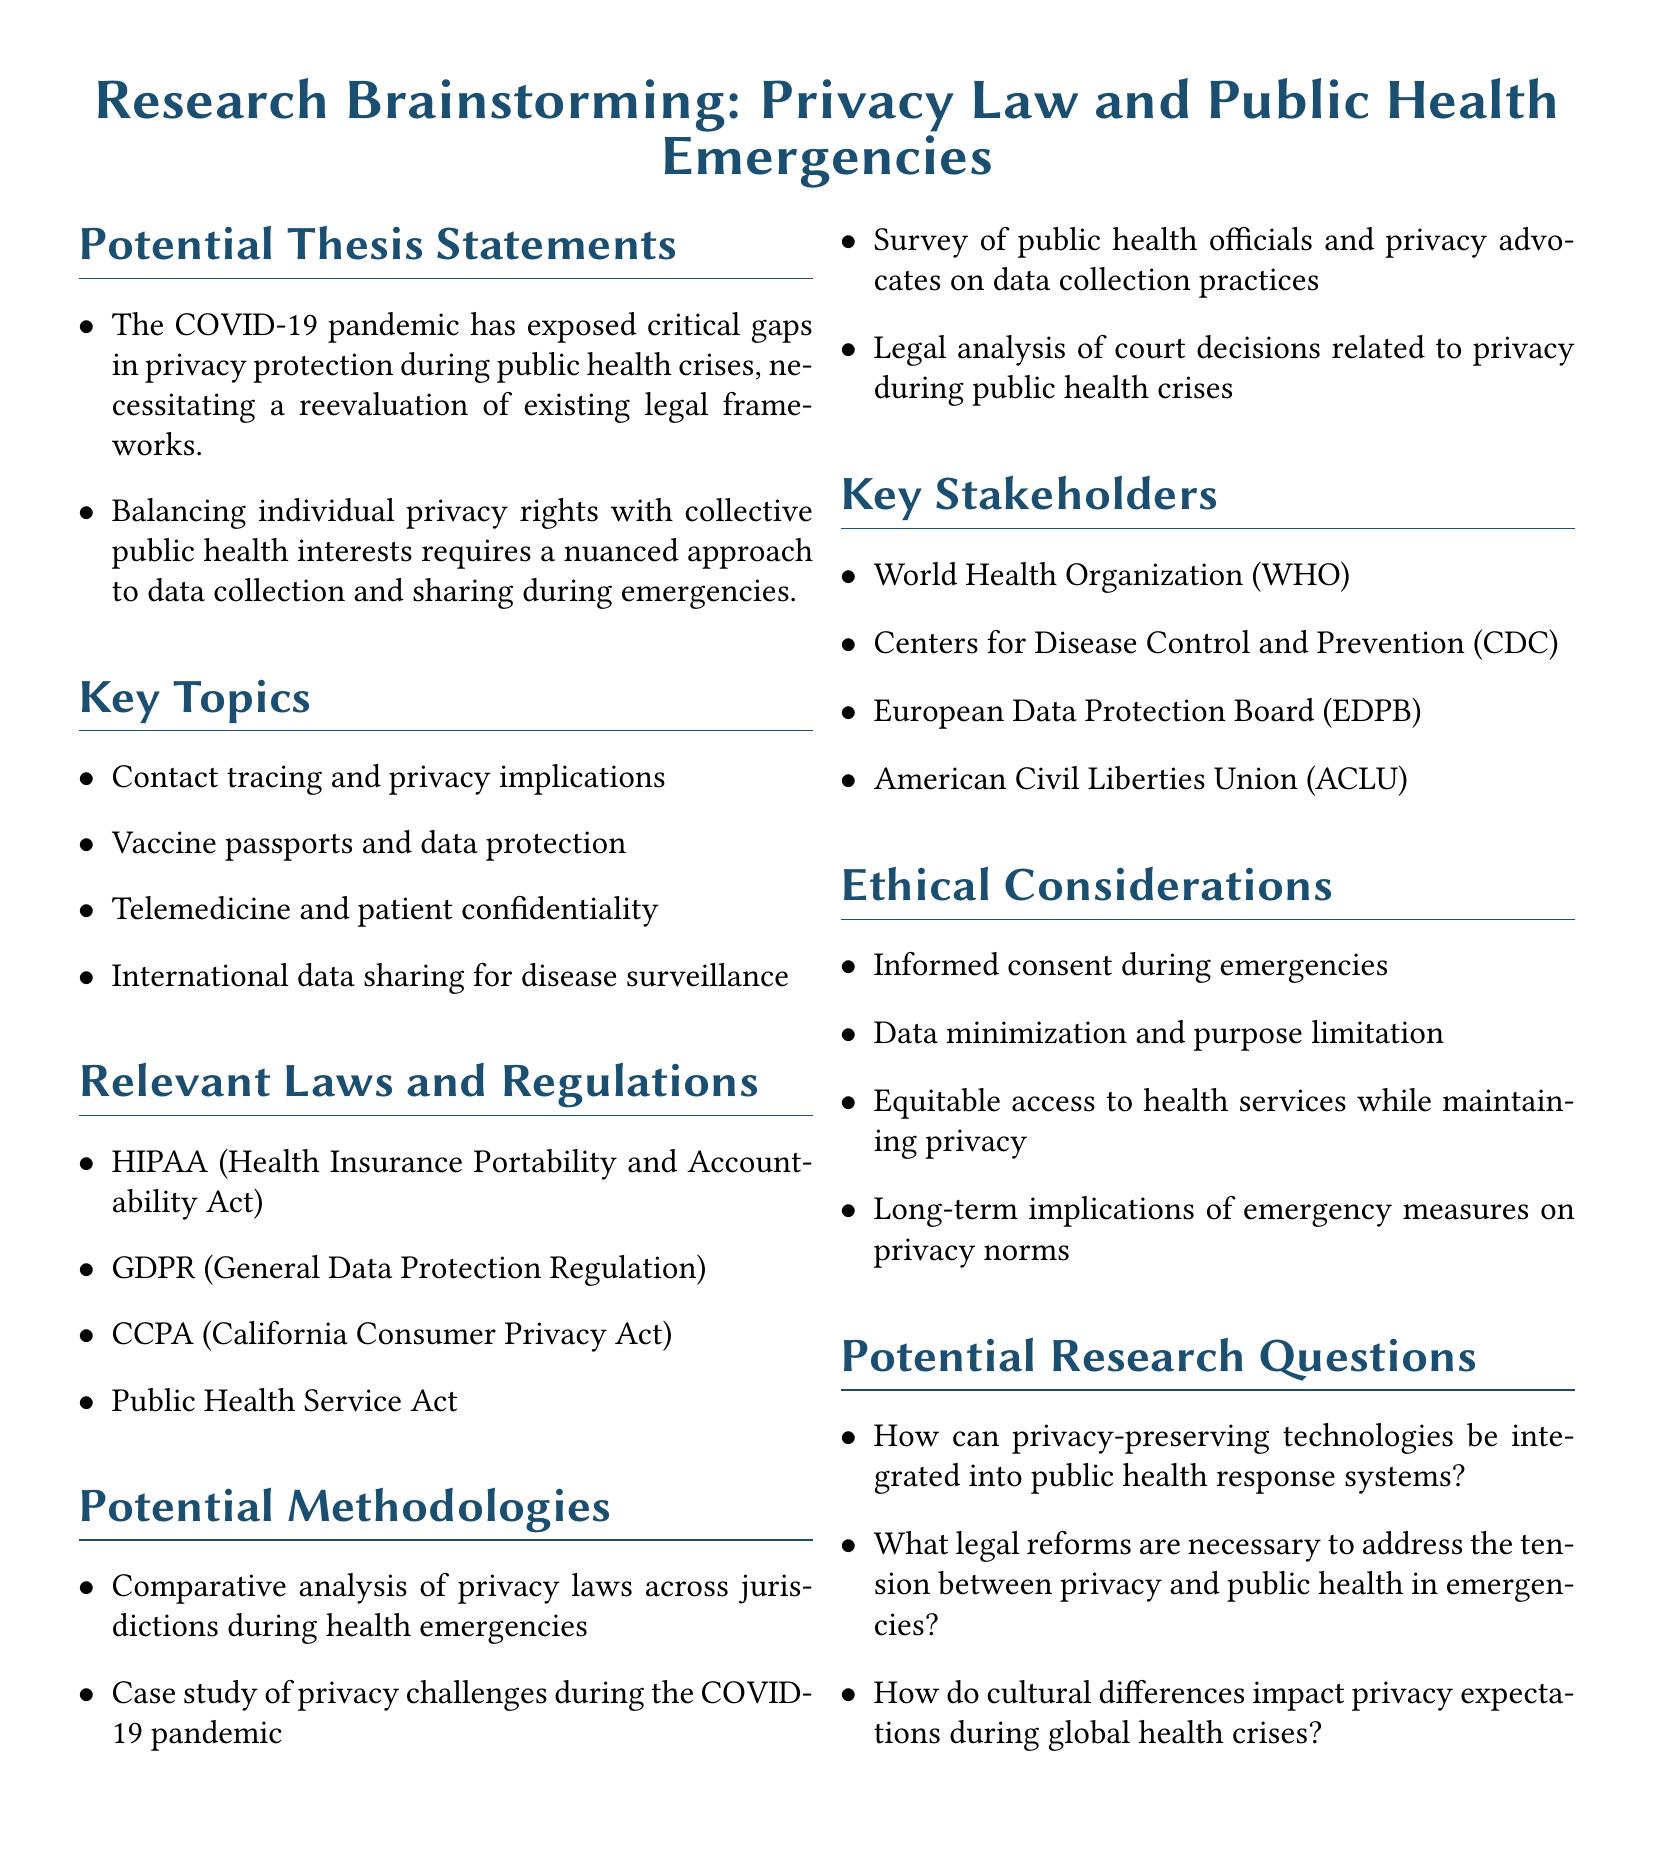What are two potential thesis statements? The document lists two potential thesis statements, highlighting concerns about privacy protection and the balance between privacy rights and public health.
Answer: The COVID-19 pandemic has exposed critical gaps in privacy protection during public health crises, necessitating a reevaluation of existing legal frameworks. Balancing individual privacy rights with collective public health interests requires a nuanced approach to data collection and sharing during emergencies Which law focuses on health insurance portability? The document mentions specific laws relevant to privacy and public health, including one that pertains to health insurance.
Answer: HIPAA (Health Insurance Portability and Accountability Act) What is one ethical consideration mentioned? The document provides a list of ethical considerations, one of which pertains to informed consent.
Answer: Informed consent during emergencies How many key stakeholders are listed? The document outlines key stakeholders involved in the intersection of privacy law and public health emergencies.
Answer: Four What research methodology involves case studies? The document describes various methodologies that can be used in research, including one that specifically focuses on case studies.
Answer: Case study of privacy challenges during the COVID-19 pandemic What is one key topic related to telemedicine? The document outlines key topics that connect privacy law and public health emergencies, including telemedicine.
Answer: Telemedicine and patient confidentiality 